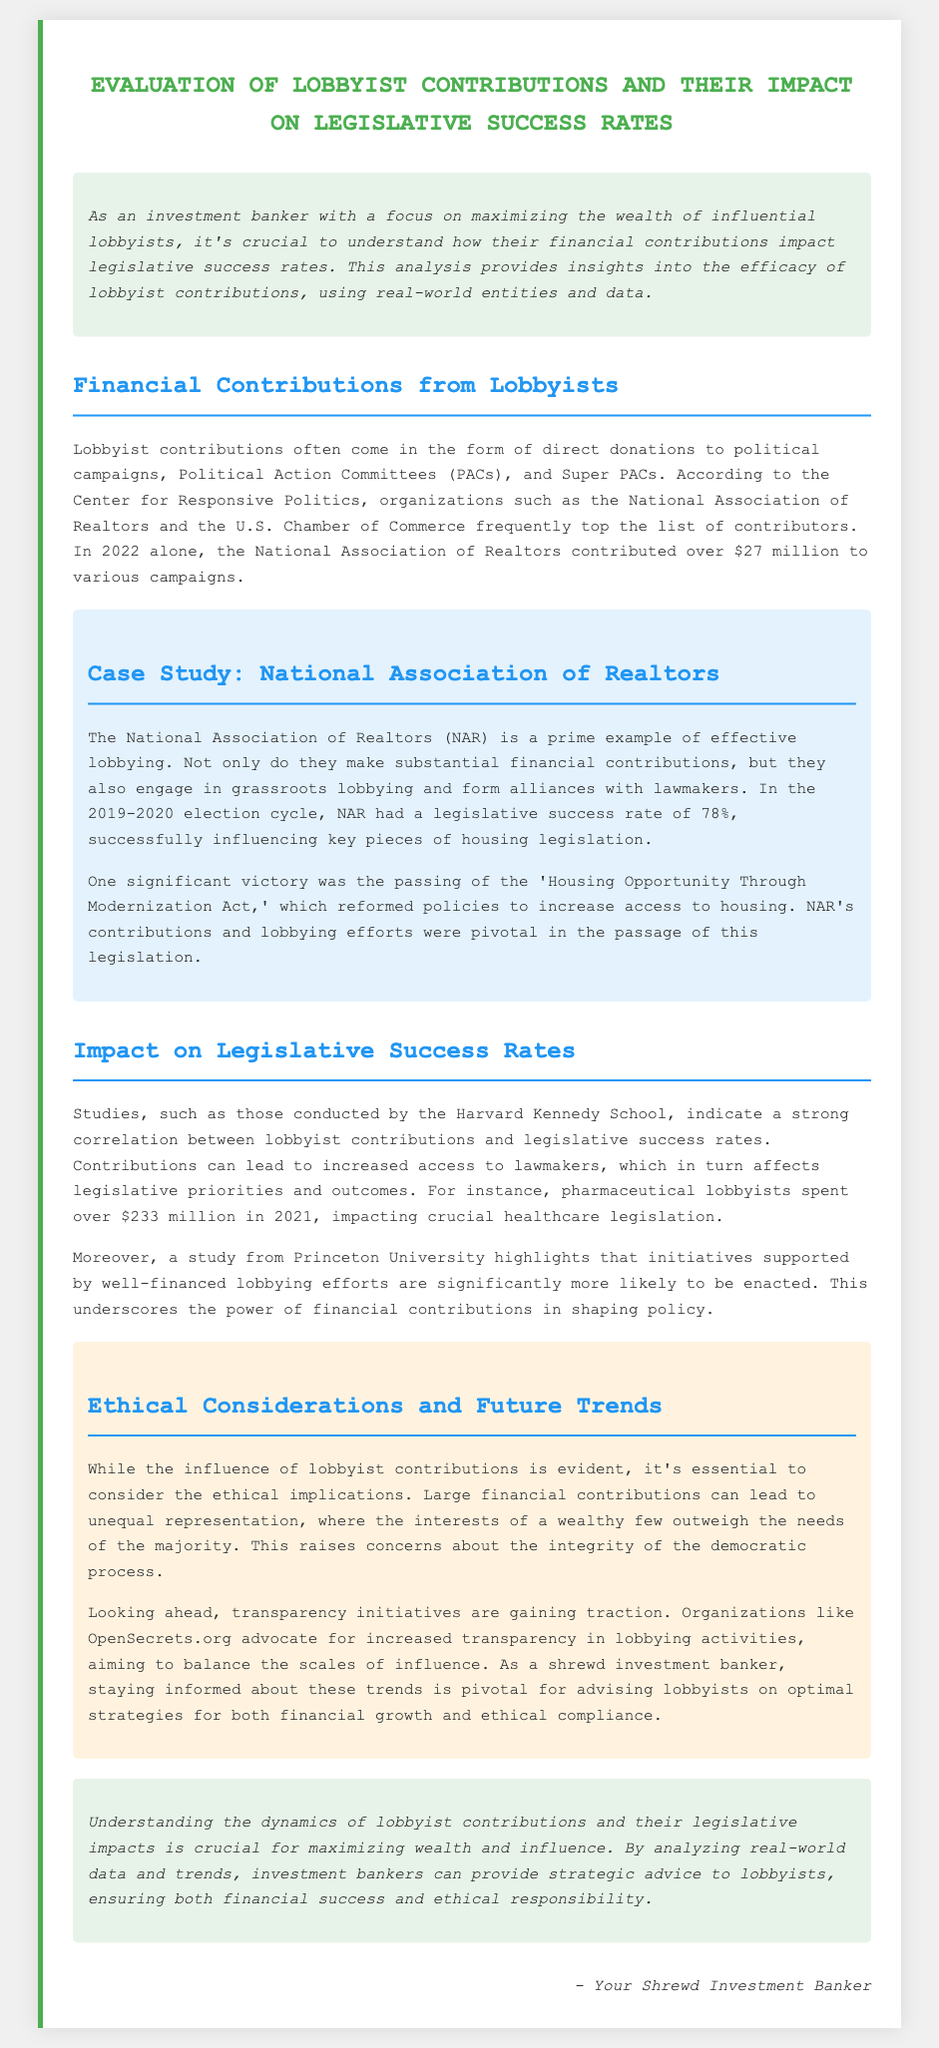What was the contribution amount from the National Association of Realtors in 2022? The document states that the National Association of Realtors contributed over $27 million in 2022.
Answer: over $27 million What was the legislative success rate of the National Association of Realtors during the 2019-2020 election cycle? According to the case study, the National Association of Realtors had a legislative success rate of 78%.
Answer: 78% How much did pharmaceutical lobbyists spend in 2021? The document indicates that pharmaceutical lobbyists spent over $233 million in 2021.
Answer: over $233 million What ethical concern is raised about lobbyist contributions? The document highlights that large financial contributions can lead to unequal representation.
Answer: unequal representation Which organization advocates for increased transparency in lobbying activities? The document mentions OpenSecrets.org as an organization advocating for transparency.
Answer: OpenSecrets.org What significant legislation was passed with the help of lobbyist contributions? The 'Housing Opportunity Through Modernization Act' is highlighted as a significant legislation passed.
Answer: Housing Opportunity Through Modernization Act What is one of the key insights from the Harvard Kennedy School study regarding lobbyist contributions? The study indicates a strong correlation between lobbyist contributions and legislative success rates.
Answer: strong correlation What is a trend mentioned for the future regarding lobbying? The document mentions that transparency initiatives are gaining traction.
Answer: transparency initiatives 